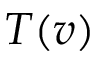<formula> <loc_0><loc_0><loc_500><loc_500>T ( v )</formula> 